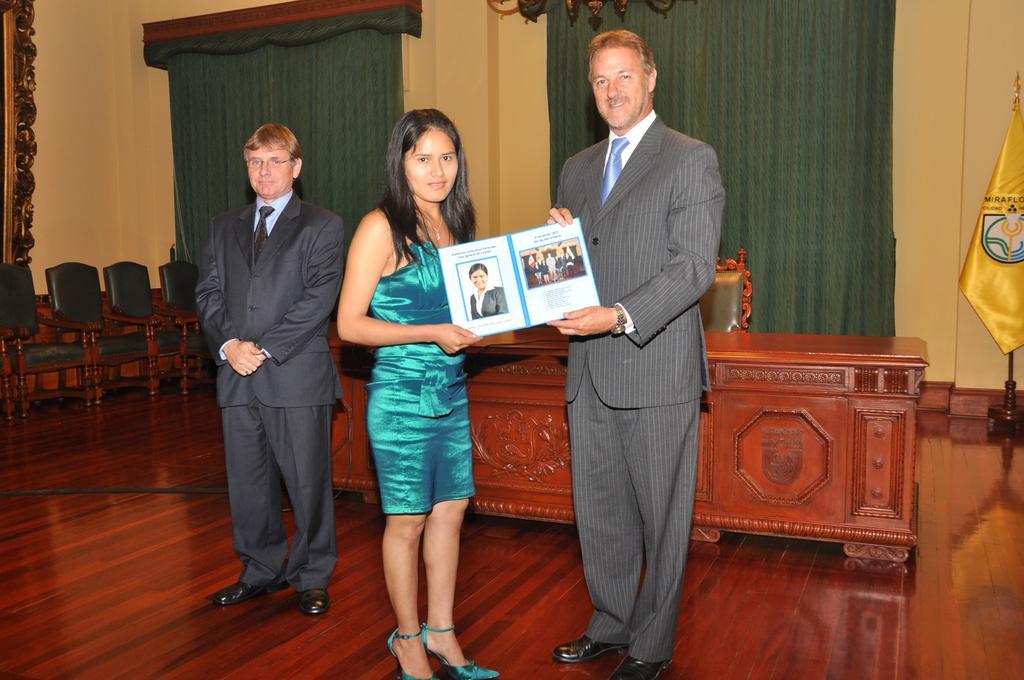Can you describe this image briefly? In the center of the image there is a man and woman holding a book. On the left side of the image we can see chairs and person. In the background we can see flag, table, curtains and wall. 